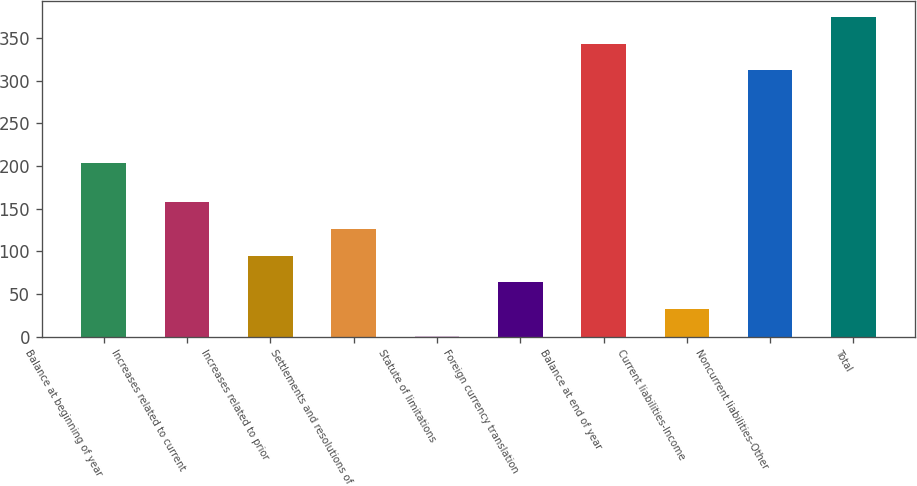<chart> <loc_0><loc_0><loc_500><loc_500><bar_chart><fcel>Balance at beginning of year<fcel>Increases related to current<fcel>Increases related to prior<fcel>Settlements and resolutions of<fcel>Statute of limitations<fcel>Foreign currency translation<fcel>Balance at end of year<fcel>Current liabilities-Income<fcel>Noncurrent liabilities-Other<fcel>Total<nl><fcel>204<fcel>158<fcel>95.2<fcel>126.6<fcel>1<fcel>63.8<fcel>343.4<fcel>32.4<fcel>312<fcel>374.8<nl></chart> 